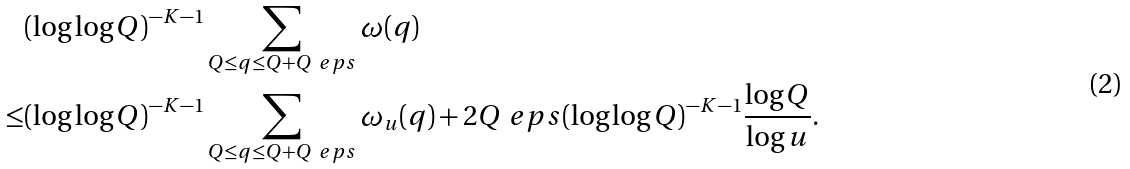<formula> <loc_0><loc_0><loc_500><loc_500>& ( \log \log Q ) ^ { - K - 1 } \sum _ { Q \leq q \leq Q + Q ^ { \ } e p s } \omega ( q ) \\ \leq & ( \log \log Q ) ^ { - K - 1 } \sum _ { Q \leq q \leq Q + Q ^ { \ } e p s } \omega _ { u } ( q ) + 2 Q ^ { \ } e p s ( \log \log Q ) ^ { - K - 1 } \frac { \log Q } { \log u } .</formula> 